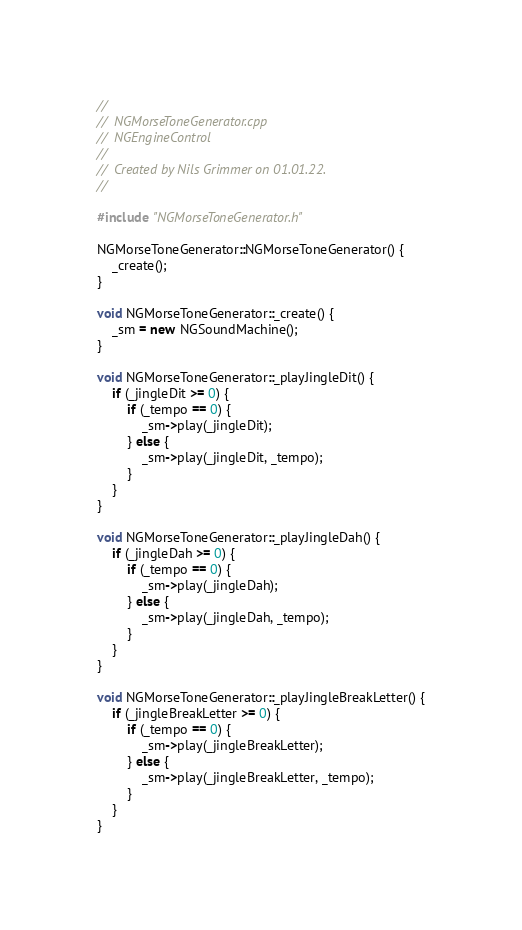<code> <loc_0><loc_0><loc_500><loc_500><_C++_>//
//  NGMorseToneGenerator.cpp
//  NGEngineControl
//
//  Created by Nils Grimmer on 01.01.22.
//

#include "NGMorseToneGenerator.h"

NGMorseToneGenerator::NGMorseToneGenerator() {
    _create();
}

void NGMorseToneGenerator::_create() {
    _sm = new NGSoundMachine();
}

void NGMorseToneGenerator::_playJingleDit() {
    if (_jingleDit >= 0) {
        if (_tempo == 0) {
            _sm->play(_jingleDit);
        } else {
            _sm->play(_jingleDit, _tempo);
        }
    }
}

void NGMorseToneGenerator::_playJingleDah() {
    if (_jingleDah >= 0) {
        if (_tempo == 0) {
            _sm->play(_jingleDah);
        } else {
            _sm->play(_jingleDah, _tempo);
        }
    }
}

void NGMorseToneGenerator::_playJingleBreakLetter() {
    if (_jingleBreakLetter >= 0) {
        if (_tempo == 0) {
            _sm->play(_jingleBreakLetter);
        } else {
            _sm->play(_jingleBreakLetter, _tempo);
        }
    }
}
</code> 